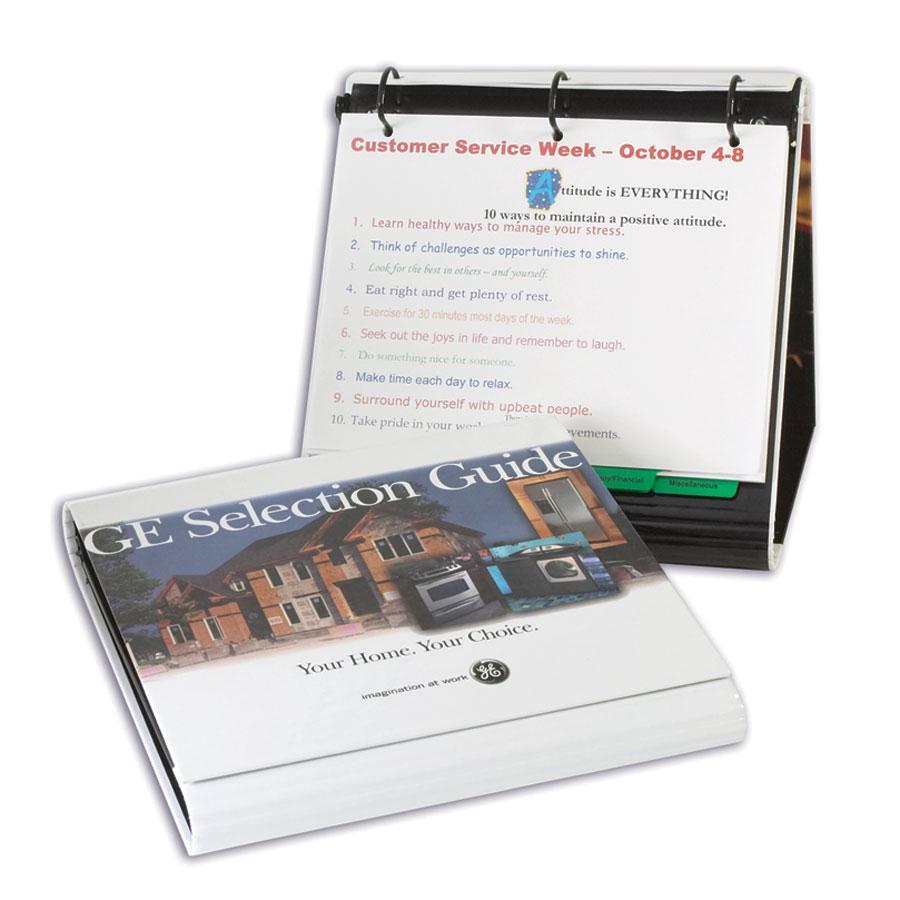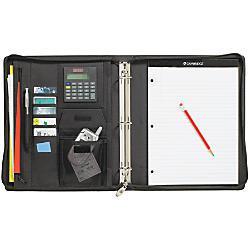The first image is the image on the left, the second image is the image on the right. For the images displayed, is the sentence "Four versions of a binder are standing in a row and overlapping each other." factually correct? Answer yes or no. No. The first image is the image on the left, the second image is the image on the right. Considering the images on both sides, is "The right image contains at least one open binder and one closed binder." valid? Answer yes or no. No. 